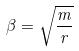Convert formula to latex. <formula><loc_0><loc_0><loc_500><loc_500>\beta = \sqrt { \frac { m } { r } }</formula> 